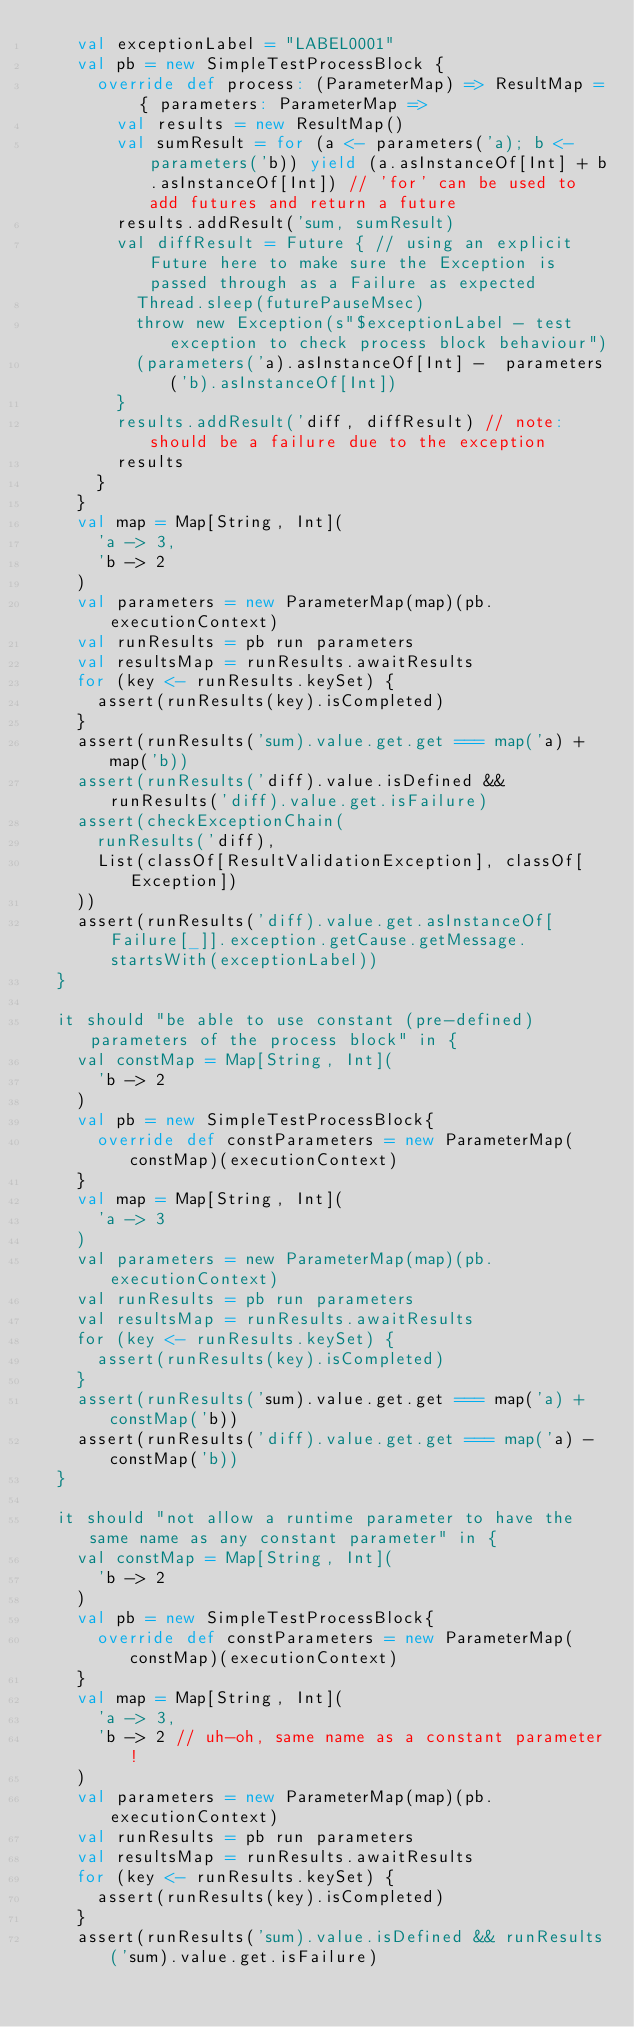Convert code to text. <code><loc_0><loc_0><loc_500><loc_500><_Scala_>    val exceptionLabel = "LABEL0001"
    val pb = new SimpleTestProcessBlock {
      override def process: (ParameterMap) => ResultMap = { parameters: ParameterMap =>
        val results = new ResultMap()
        val sumResult = for (a <- parameters('a); b <- parameters('b)) yield (a.asInstanceOf[Int] + b.asInstanceOf[Int]) // 'for' can be used to add futures and return a future
        results.addResult('sum, sumResult)
        val diffResult = Future { // using an explicit Future here to make sure the Exception is passed through as a Failure as expected
          Thread.sleep(futurePauseMsec)
          throw new Exception(s"$exceptionLabel - test exception to check process block behaviour")
          (parameters('a).asInstanceOf[Int] -  parameters('b).asInstanceOf[Int])
        }
        results.addResult('diff, diffResult) // note: should be a failure due to the exception
        results
      }
    }
    val map = Map[String, Int](
      'a -> 3,
      'b -> 2
    )
    val parameters = new ParameterMap(map)(pb.executionContext)
    val runResults = pb run parameters
    val resultsMap = runResults.awaitResults
    for (key <- runResults.keySet) {
      assert(runResults(key).isCompleted)
    }
    assert(runResults('sum).value.get.get === map('a) + map('b))
    assert(runResults('diff).value.isDefined && runResults('diff).value.get.isFailure)
    assert(checkExceptionChain(
      runResults('diff),
      List(classOf[ResultValidationException], classOf[Exception])
    ))
    assert(runResults('diff).value.get.asInstanceOf[Failure[_]].exception.getCause.getMessage.startsWith(exceptionLabel))
  }

  it should "be able to use constant (pre-defined) parameters of the process block" in {
    val constMap = Map[String, Int](
      'b -> 2
    )
    val pb = new SimpleTestProcessBlock{
      override def constParameters = new ParameterMap(constMap)(executionContext)
    }
    val map = Map[String, Int](
      'a -> 3
    )
    val parameters = new ParameterMap(map)(pb.executionContext)
    val runResults = pb run parameters
    val resultsMap = runResults.awaitResults
    for (key <- runResults.keySet) {
      assert(runResults(key).isCompleted)
    }
    assert(runResults('sum).value.get.get === map('a) + constMap('b))
    assert(runResults('diff).value.get.get === map('a) - constMap('b))
  }

  it should "not allow a runtime parameter to have the same name as any constant parameter" in {
    val constMap = Map[String, Int](
      'b -> 2
    )
    val pb = new SimpleTestProcessBlock{
      override def constParameters = new ParameterMap(constMap)(executionContext)
    }
    val map = Map[String, Int](
      'a -> 3,
      'b -> 2 // uh-oh, same name as a constant parameter!
    )
    val parameters = new ParameterMap(map)(pb.executionContext)
    val runResults = pb run parameters
    val resultsMap = runResults.awaitResults
    for (key <- runResults.keySet) {
      assert(runResults(key).isCompleted)
    }
    assert(runResults('sum).value.isDefined && runResults('sum).value.get.isFailure)</code> 